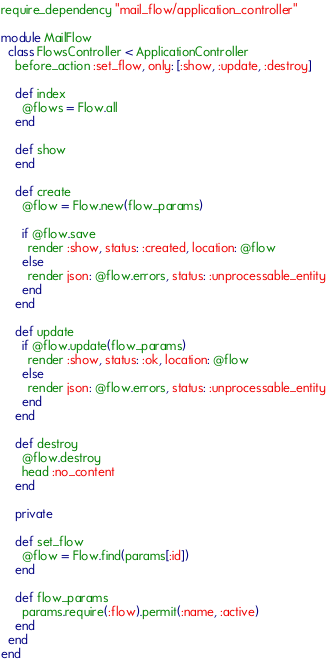Convert code to text. <code><loc_0><loc_0><loc_500><loc_500><_Ruby_>require_dependency "mail_flow/application_controller"

module MailFlow
  class FlowsController < ApplicationController
    before_action :set_flow, only: [:show, :update, :destroy]

    def index
      @flows = Flow.all
    end

    def show
    end

    def create
      @flow = Flow.new(flow_params)

      if @flow.save
        render :show, status: :created, location: @flow
      else
        render json: @flow.errors, status: :unprocessable_entity
      end
    end

    def update
      if @flow.update(flow_params)
        render :show, status: :ok, location: @flow
      else
        render json: @flow.errors, status: :unprocessable_entity
      end
    end

    def destroy
      @flow.destroy
      head :no_content
    end

    private

    def set_flow
      @flow = Flow.find(params[:id])
    end

    def flow_params
      params.require(:flow).permit(:name, :active)
    end
  end
end
</code> 